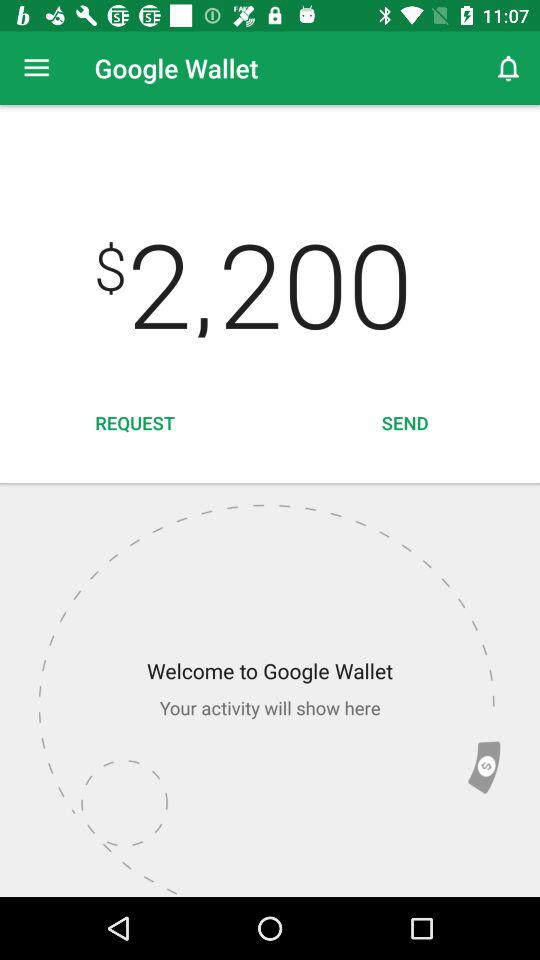How much money has been sent?
When the provided information is insufficient, respond with <no answer>. <no answer> 